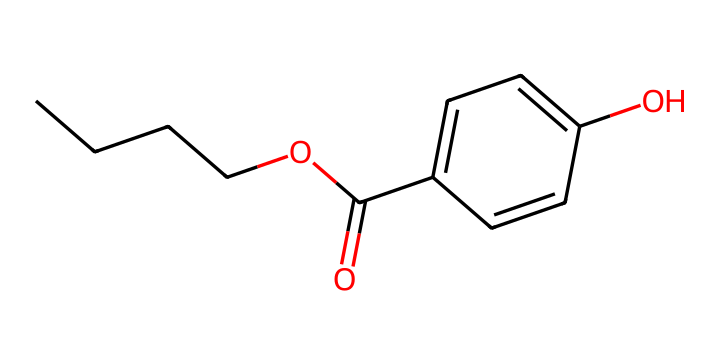How many carbon atoms are in this chemical? By analyzing the SMILES representation, we can count the number of carbon atoms. The "C" indicates carbon, and we see "CCCC" (4 carbon atoms in a straight chain) and "c1ccc" (4 additional carbon atoms in the aromatic ring). Adding these gives us a total of 8 carbon atoms.
Answer: 8 What type of chemical is this? Based on the structure and the presence of phenolic (from the "c" atoms in the ring) and aliphatic components, this chemical can be classified as a phenolic antioxidant.
Answer: phenolic antioxidant Does this chemical contain a hydroxyl group? Examining the SMILES representation, we see the "O" after "c" in "O)cc" which indicates the presence of an OH group, confirming the hydroxyl group is present.
Answer: yes How many oxygen atoms are in this compound? In the provided SMILES, there are two oxygen atoms: one from the ester group "OC(=O)" and one from the hydroxyl "O". Thus, we count 2 oxygen atoms in total.
Answer: 2 What type of bond connects the carbon chain to the aromatic ring? The structure indicates a single bond is connecting the carbon chain (CCCC) with the aromatic ring (c1ccc). The absence of double bonds in that portion confirms this.
Answer: single bond Does this chemical have antioxidant properties? Being a phenolic structure, it is known for its ability to donate hydrogen atoms or electrons, making it effective in preventing oxidation and thus possessing antioxidant properties.
Answer: yes 